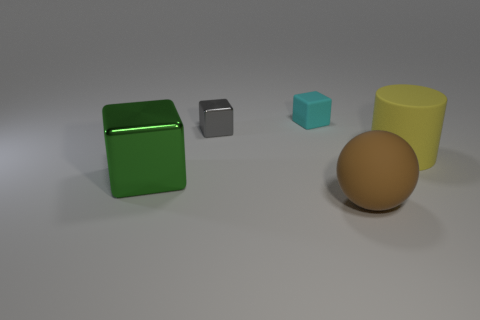Do the cylinder and the rubber ball have the same color?
Make the answer very short. No. How many brown things are in front of the large brown rubber object?
Offer a very short reply. 0. There is a brown matte object; does it have the same shape as the tiny object on the right side of the small metal object?
Make the answer very short. No. Is there another yellow object of the same shape as the tiny shiny object?
Make the answer very short. No. There is a tiny thing that is in front of the matte thing that is behind the big yellow rubber cylinder; what is its shape?
Ensure brevity in your answer.  Cube. There is a small thing to the right of the small gray cube; what shape is it?
Your response must be concise. Cube. There is a shiny thing in front of the gray object; is it the same color as the small object on the left side of the small cyan object?
Your answer should be very brief. No. What number of big things are in front of the yellow object and right of the brown matte object?
Give a very brief answer. 0. There is a brown sphere that is the same material as the yellow thing; what size is it?
Your answer should be very brief. Large. How big is the cyan cube?
Make the answer very short. Small. 